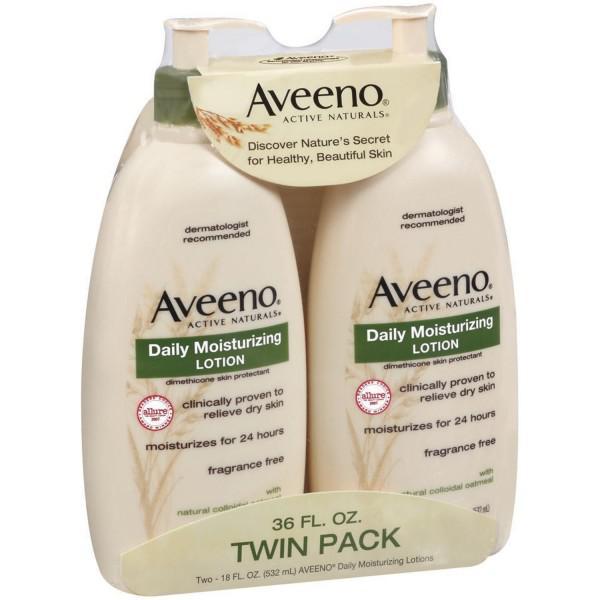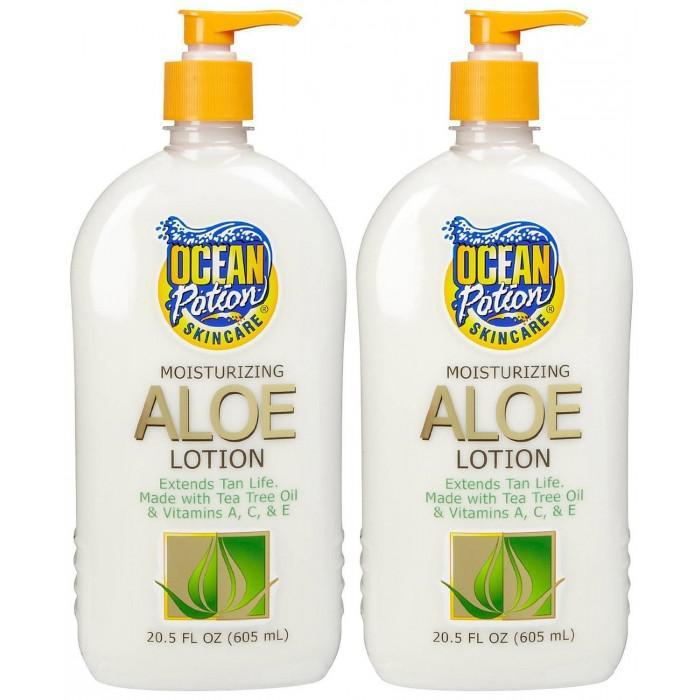The first image is the image on the left, the second image is the image on the right. Considering the images on both sides, is "There are two dispensers pointing right in one of the images." valid? Answer yes or no. Yes. The first image is the image on the left, the second image is the image on the right. Given the left and right images, does the statement "An image features two unwrapped pump bottles with nozzles turned rightward." hold true? Answer yes or no. Yes. 